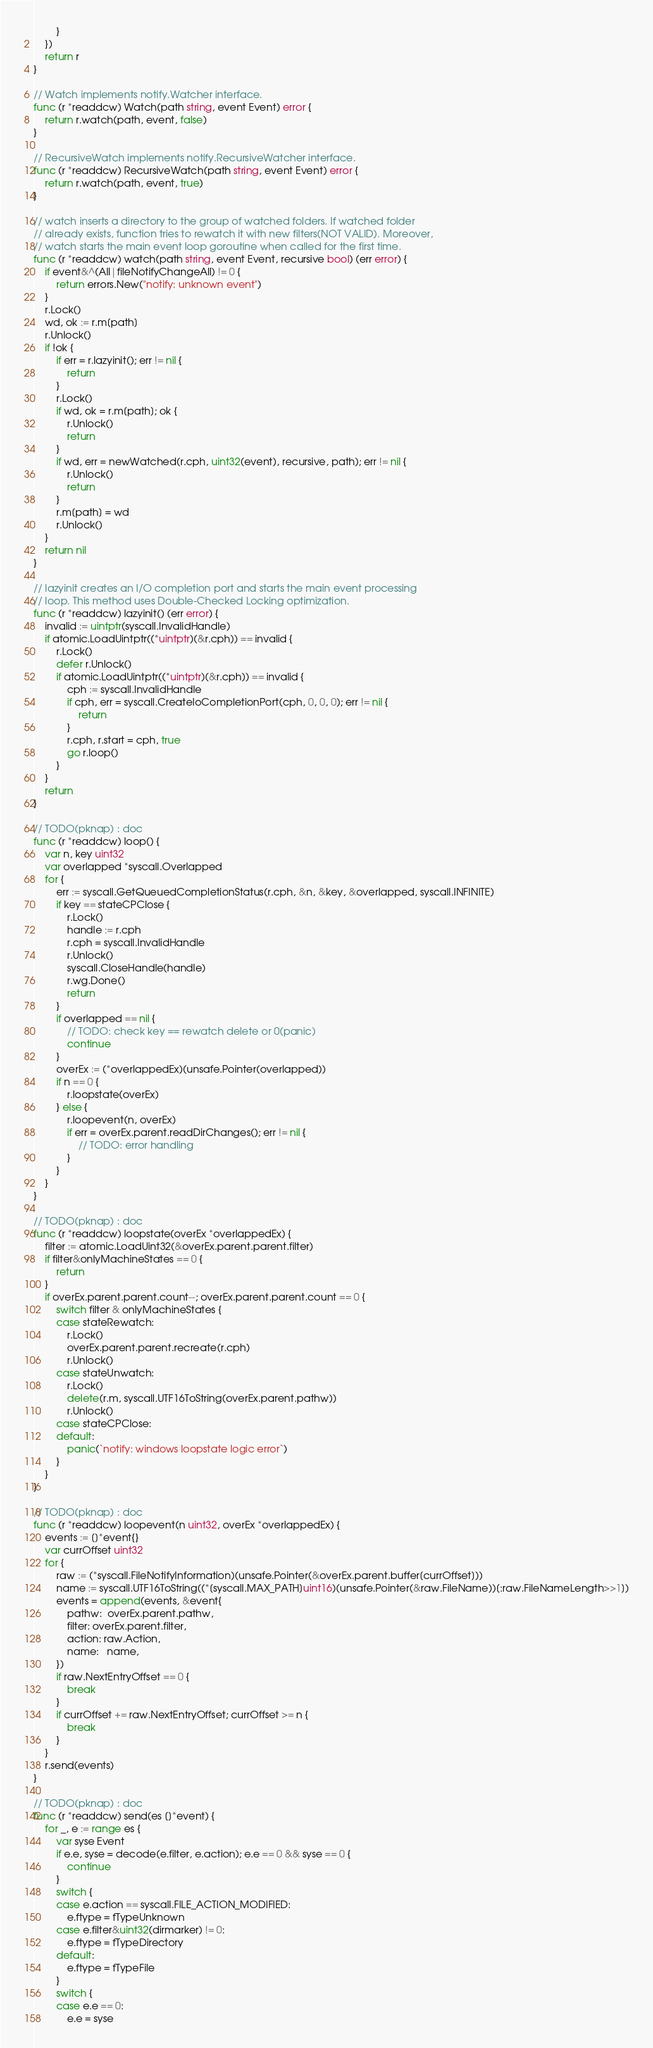Convert code to text. <code><loc_0><loc_0><loc_500><loc_500><_Go_>		}
	})
	return r
}

// Watch implements notify.Watcher interface.
func (r *readdcw) Watch(path string, event Event) error {
	return r.watch(path, event, false)
}

// RecursiveWatch implements notify.RecursiveWatcher interface.
func (r *readdcw) RecursiveWatch(path string, event Event) error {
	return r.watch(path, event, true)
}

// watch inserts a directory to the group of watched folders. If watched folder
// already exists, function tries to rewatch it with new filters(NOT VALID). Moreover,
// watch starts the main event loop goroutine when called for the first time.
func (r *readdcw) watch(path string, event Event, recursive bool) (err error) {
	if event&^(All|fileNotifyChangeAll) != 0 {
		return errors.New("notify: unknown event")
	}
	r.Lock()
	wd, ok := r.m[path]
	r.Unlock()
	if !ok {
		if err = r.lazyinit(); err != nil {
			return
		}
		r.Lock()
		if wd, ok = r.m[path]; ok {
			r.Unlock()
			return
		}
		if wd, err = newWatched(r.cph, uint32(event), recursive, path); err != nil {
			r.Unlock()
			return
		}
		r.m[path] = wd
		r.Unlock()
	}
	return nil
}

// lazyinit creates an I/O completion port and starts the main event processing
// loop. This method uses Double-Checked Locking optimization.
func (r *readdcw) lazyinit() (err error) {
	invalid := uintptr(syscall.InvalidHandle)
	if atomic.LoadUintptr((*uintptr)(&r.cph)) == invalid {
		r.Lock()
		defer r.Unlock()
		if atomic.LoadUintptr((*uintptr)(&r.cph)) == invalid {
			cph := syscall.InvalidHandle
			if cph, err = syscall.CreateIoCompletionPort(cph, 0, 0, 0); err != nil {
				return
			}
			r.cph, r.start = cph, true
			go r.loop()
		}
	}
	return
}

// TODO(pknap) : doc
func (r *readdcw) loop() {
	var n, key uint32
	var overlapped *syscall.Overlapped
	for {
		err := syscall.GetQueuedCompletionStatus(r.cph, &n, &key, &overlapped, syscall.INFINITE)
		if key == stateCPClose {
			r.Lock()
			handle := r.cph
			r.cph = syscall.InvalidHandle
			r.Unlock()
			syscall.CloseHandle(handle)
			r.wg.Done()
			return
		}
		if overlapped == nil {
			// TODO: check key == rewatch delete or 0(panic)
			continue
		}
		overEx := (*overlappedEx)(unsafe.Pointer(overlapped))
		if n == 0 {
			r.loopstate(overEx)
		} else {
			r.loopevent(n, overEx)
			if err = overEx.parent.readDirChanges(); err != nil {
				// TODO: error handling
			}
		}
	}
}

// TODO(pknap) : doc
func (r *readdcw) loopstate(overEx *overlappedEx) {
	filter := atomic.LoadUint32(&overEx.parent.parent.filter)
	if filter&onlyMachineStates == 0 {
		return
	}
	if overEx.parent.parent.count--; overEx.parent.parent.count == 0 {
		switch filter & onlyMachineStates {
		case stateRewatch:
			r.Lock()
			overEx.parent.parent.recreate(r.cph)
			r.Unlock()
		case stateUnwatch:
			r.Lock()
			delete(r.m, syscall.UTF16ToString(overEx.parent.pathw))
			r.Unlock()
		case stateCPClose:
		default:
			panic(`notify: windows loopstate logic error`)
		}
	}
}

// TODO(pknap) : doc
func (r *readdcw) loopevent(n uint32, overEx *overlappedEx) {
	events := []*event{}
	var currOffset uint32
	for {
		raw := (*syscall.FileNotifyInformation)(unsafe.Pointer(&overEx.parent.buffer[currOffset]))
		name := syscall.UTF16ToString((*[syscall.MAX_PATH]uint16)(unsafe.Pointer(&raw.FileName))[:raw.FileNameLength>>1])
		events = append(events, &event{
			pathw:  overEx.parent.pathw,
			filter: overEx.parent.filter,
			action: raw.Action,
			name:   name,
		})
		if raw.NextEntryOffset == 0 {
			break
		}
		if currOffset += raw.NextEntryOffset; currOffset >= n {
			break
		}
	}
	r.send(events)
}

// TODO(pknap) : doc
func (r *readdcw) send(es []*event) {
	for _, e := range es {
		var syse Event
		if e.e, syse = decode(e.filter, e.action); e.e == 0 && syse == 0 {
			continue
		}
		switch {
		case e.action == syscall.FILE_ACTION_MODIFIED:
			e.ftype = fTypeUnknown
		case e.filter&uint32(dirmarker) != 0:
			e.ftype = fTypeDirectory
		default:
			e.ftype = fTypeFile
		}
		switch {
		case e.e == 0:
			e.e = syse</code> 